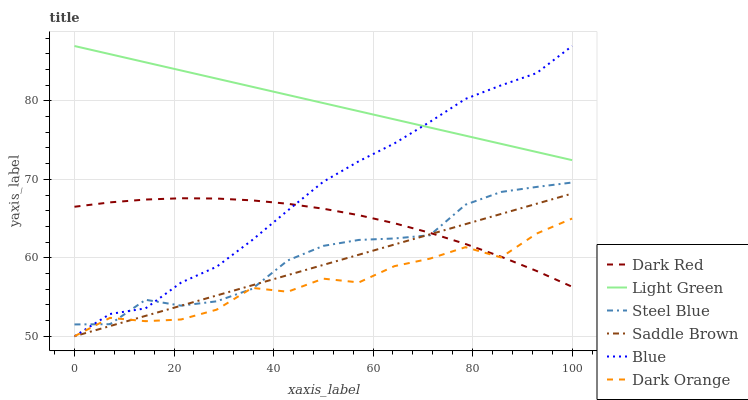Does Dark Orange have the minimum area under the curve?
Answer yes or no. Yes. Does Light Green have the maximum area under the curve?
Answer yes or no. Yes. Does Dark Red have the minimum area under the curve?
Answer yes or no. No. Does Dark Red have the maximum area under the curve?
Answer yes or no. No. Is Saddle Brown the smoothest?
Answer yes or no. Yes. Is Dark Orange the roughest?
Answer yes or no. Yes. Is Dark Red the smoothest?
Answer yes or no. No. Is Dark Red the roughest?
Answer yes or no. No. Does Dark Red have the lowest value?
Answer yes or no. No. Does Light Green have the highest value?
Answer yes or no. Yes. Does Dark Red have the highest value?
Answer yes or no. No. Is Steel Blue less than Light Green?
Answer yes or no. Yes. Is Light Green greater than Steel Blue?
Answer yes or no. Yes. Does Saddle Brown intersect Steel Blue?
Answer yes or no. Yes. Is Saddle Brown less than Steel Blue?
Answer yes or no. No. Is Saddle Brown greater than Steel Blue?
Answer yes or no. No. Does Steel Blue intersect Light Green?
Answer yes or no. No. 